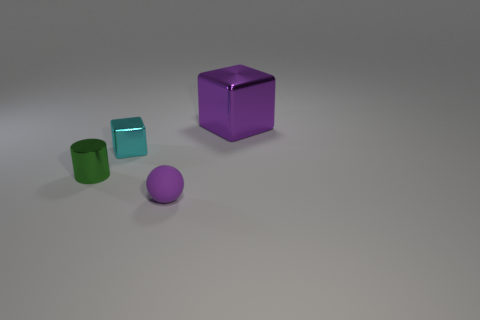What number of other things are there of the same shape as the small cyan object?
Offer a very short reply. 1. Are there any cylinders?
Offer a terse response. Yes. How many things are cyan objects or small purple matte things that are left of the large shiny cube?
Give a very brief answer. 2. There is a object that is right of the purple ball; is its size the same as the tiny block?
Keep it short and to the point. No. What number of other things are the same size as the green metal cylinder?
Your answer should be compact. 2. The tiny cube has what color?
Ensure brevity in your answer.  Cyan. What is the object that is left of the cyan cube made of?
Keep it short and to the point. Metal. Are there an equal number of small things that are in front of the purple rubber thing and small cyan blocks?
Offer a terse response. No. Does the purple metal thing have the same shape as the tiny purple rubber thing?
Offer a terse response. No. Is there any other thing that is the same color as the small rubber ball?
Offer a very short reply. Yes. 